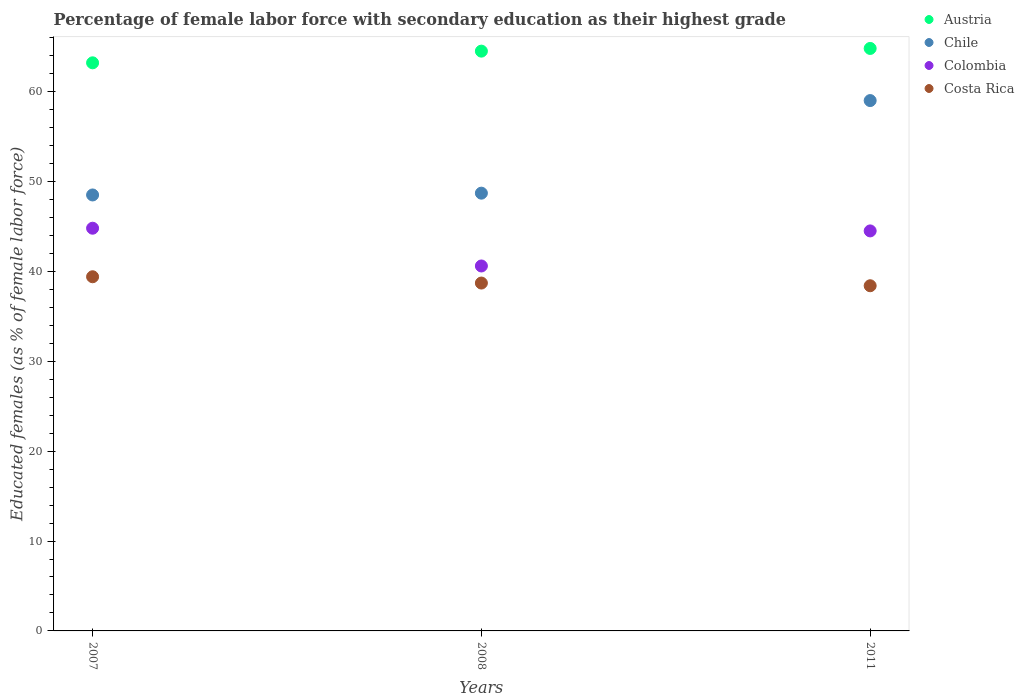How many different coloured dotlines are there?
Keep it short and to the point. 4. Is the number of dotlines equal to the number of legend labels?
Your answer should be compact. Yes. What is the percentage of female labor force with secondary education in Chile in 2007?
Offer a very short reply. 48.5. Across all years, what is the maximum percentage of female labor force with secondary education in Costa Rica?
Ensure brevity in your answer.  39.4. Across all years, what is the minimum percentage of female labor force with secondary education in Chile?
Your answer should be very brief. 48.5. In which year was the percentage of female labor force with secondary education in Chile minimum?
Make the answer very short. 2007. What is the total percentage of female labor force with secondary education in Chile in the graph?
Your answer should be compact. 156.2. What is the difference between the percentage of female labor force with secondary education in Colombia in 2007 and that in 2011?
Make the answer very short. 0.3. What is the difference between the percentage of female labor force with secondary education in Chile in 2011 and the percentage of female labor force with secondary education in Colombia in 2008?
Make the answer very short. 18.4. What is the average percentage of female labor force with secondary education in Chile per year?
Your answer should be compact. 52.07. In how many years, is the percentage of female labor force with secondary education in Colombia greater than 20 %?
Give a very brief answer. 3. What is the ratio of the percentage of female labor force with secondary education in Costa Rica in 2008 to that in 2011?
Give a very brief answer. 1.01. Is the difference between the percentage of female labor force with secondary education in Costa Rica in 2007 and 2011 greater than the difference between the percentage of female labor force with secondary education in Chile in 2007 and 2011?
Keep it short and to the point. Yes. What is the difference between the highest and the second highest percentage of female labor force with secondary education in Austria?
Offer a very short reply. 0.3. In how many years, is the percentage of female labor force with secondary education in Chile greater than the average percentage of female labor force with secondary education in Chile taken over all years?
Your answer should be very brief. 1. Is it the case that in every year, the sum of the percentage of female labor force with secondary education in Austria and percentage of female labor force with secondary education in Chile  is greater than the percentage of female labor force with secondary education in Colombia?
Make the answer very short. Yes. Is the percentage of female labor force with secondary education in Colombia strictly greater than the percentage of female labor force with secondary education in Austria over the years?
Provide a succinct answer. No. Is the percentage of female labor force with secondary education in Austria strictly less than the percentage of female labor force with secondary education in Chile over the years?
Make the answer very short. No. How many dotlines are there?
Provide a succinct answer. 4. How many years are there in the graph?
Give a very brief answer. 3. What is the difference between two consecutive major ticks on the Y-axis?
Your answer should be very brief. 10. Are the values on the major ticks of Y-axis written in scientific E-notation?
Your answer should be very brief. No. Where does the legend appear in the graph?
Your answer should be compact. Top right. How many legend labels are there?
Provide a short and direct response. 4. How are the legend labels stacked?
Keep it short and to the point. Vertical. What is the title of the graph?
Make the answer very short. Percentage of female labor force with secondary education as their highest grade. Does "Tunisia" appear as one of the legend labels in the graph?
Give a very brief answer. No. What is the label or title of the Y-axis?
Your response must be concise. Educated females (as % of female labor force). What is the Educated females (as % of female labor force) of Austria in 2007?
Make the answer very short. 63.2. What is the Educated females (as % of female labor force) in Chile in 2007?
Provide a succinct answer. 48.5. What is the Educated females (as % of female labor force) of Colombia in 2007?
Provide a short and direct response. 44.8. What is the Educated females (as % of female labor force) of Costa Rica in 2007?
Your answer should be compact. 39.4. What is the Educated females (as % of female labor force) in Austria in 2008?
Make the answer very short. 64.5. What is the Educated females (as % of female labor force) of Chile in 2008?
Keep it short and to the point. 48.7. What is the Educated females (as % of female labor force) in Colombia in 2008?
Provide a succinct answer. 40.6. What is the Educated females (as % of female labor force) of Costa Rica in 2008?
Provide a short and direct response. 38.7. What is the Educated females (as % of female labor force) of Austria in 2011?
Ensure brevity in your answer.  64.8. What is the Educated females (as % of female labor force) of Chile in 2011?
Provide a succinct answer. 59. What is the Educated females (as % of female labor force) of Colombia in 2011?
Your answer should be very brief. 44.5. What is the Educated females (as % of female labor force) of Costa Rica in 2011?
Provide a succinct answer. 38.4. Across all years, what is the maximum Educated females (as % of female labor force) of Austria?
Give a very brief answer. 64.8. Across all years, what is the maximum Educated females (as % of female labor force) of Colombia?
Provide a succinct answer. 44.8. Across all years, what is the maximum Educated females (as % of female labor force) of Costa Rica?
Your answer should be compact. 39.4. Across all years, what is the minimum Educated females (as % of female labor force) in Austria?
Provide a succinct answer. 63.2. Across all years, what is the minimum Educated females (as % of female labor force) of Chile?
Give a very brief answer. 48.5. Across all years, what is the minimum Educated females (as % of female labor force) in Colombia?
Give a very brief answer. 40.6. Across all years, what is the minimum Educated females (as % of female labor force) of Costa Rica?
Your answer should be compact. 38.4. What is the total Educated females (as % of female labor force) in Austria in the graph?
Keep it short and to the point. 192.5. What is the total Educated females (as % of female labor force) of Chile in the graph?
Your answer should be compact. 156.2. What is the total Educated females (as % of female labor force) of Colombia in the graph?
Provide a short and direct response. 129.9. What is the total Educated females (as % of female labor force) in Costa Rica in the graph?
Make the answer very short. 116.5. What is the difference between the Educated females (as % of female labor force) in Austria in 2007 and that in 2008?
Provide a succinct answer. -1.3. What is the difference between the Educated females (as % of female labor force) of Colombia in 2007 and that in 2008?
Make the answer very short. 4.2. What is the difference between the Educated females (as % of female labor force) in Costa Rica in 2007 and that in 2008?
Provide a succinct answer. 0.7. What is the difference between the Educated females (as % of female labor force) in Austria in 2007 and that in 2011?
Give a very brief answer. -1.6. What is the difference between the Educated females (as % of female labor force) of Chile in 2007 and that in 2011?
Ensure brevity in your answer.  -10.5. What is the difference between the Educated females (as % of female labor force) of Costa Rica in 2007 and that in 2011?
Your response must be concise. 1. What is the difference between the Educated females (as % of female labor force) of Austria in 2008 and that in 2011?
Give a very brief answer. -0.3. What is the difference between the Educated females (as % of female labor force) in Chile in 2008 and that in 2011?
Offer a terse response. -10.3. What is the difference between the Educated females (as % of female labor force) in Colombia in 2008 and that in 2011?
Your response must be concise. -3.9. What is the difference between the Educated females (as % of female labor force) of Costa Rica in 2008 and that in 2011?
Give a very brief answer. 0.3. What is the difference between the Educated females (as % of female labor force) of Austria in 2007 and the Educated females (as % of female labor force) of Colombia in 2008?
Your answer should be compact. 22.6. What is the difference between the Educated females (as % of female labor force) of Chile in 2007 and the Educated females (as % of female labor force) of Costa Rica in 2008?
Offer a terse response. 9.8. What is the difference between the Educated females (as % of female labor force) of Austria in 2007 and the Educated females (as % of female labor force) of Costa Rica in 2011?
Provide a short and direct response. 24.8. What is the difference between the Educated females (as % of female labor force) in Chile in 2007 and the Educated females (as % of female labor force) in Colombia in 2011?
Provide a short and direct response. 4. What is the difference between the Educated females (as % of female labor force) in Colombia in 2007 and the Educated females (as % of female labor force) in Costa Rica in 2011?
Your answer should be compact. 6.4. What is the difference between the Educated females (as % of female labor force) in Austria in 2008 and the Educated females (as % of female labor force) in Colombia in 2011?
Your answer should be compact. 20. What is the difference between the Educated females (as % of female labor force) in Austria in 2008 and the Educated females (as % of female labor force) in Costa Rica in 2011?
Provide a succinct answer. 26.1. What is the difference between the Educated females (as % of female labor force) in Chile in 2008 and the Educated females (as % of female labor force) in Colombia in 2011?
Give a very brief answer. 4.2. What is the difference between the Educated females (as % of female labor force) in Chile in 2008 and the Educated females (as % of female labor force) in Costa Rica in 2011?
Offer a terse response. 10.3. What is the average Educated females (as % of female labor force) of Austria per year?
Provide a short and direct response. 64.17. What is the average Educated females (as % of female labor force) of Chile per year?
Ensure brevity in your answer.  52.07. What is the average Educated females (as % of female labor force) in Colombia per year?
Offer a very short reply. 43.3. What is the average Educated females (as % of female labor force) of Costa Rica per year?
Your response must be concise. 38.83. In the year 2007, what is the difference between the Educated females (as % of female labor force) in Austria and Educated females (as % of female labor force) in Chile?
Provide a short and direct response. 14.7. In the year 2007, what is the difference between the Educated females (as % of female labor force) in Austria and Educated females (as % of female labor force) in Costa Rica?
Provide a short and direct response. 23.8. In the year 2007, what is the difference between the Educated females (as % of female labor force) of Chile and Educated females (as % of female labor force) of Colombia?
Keep it short and to the point. 3.7. In the year 2007, what is the difference between the Educated females (as % of female labor force) of Chile and Educated females (as % of female labor force) of Costa Rica?
Your answer should be compact. 9.1. In the year 2007, what is the difference between the Educated females (as % of female labor force) of Colombia and Educated females (as % of female labor force) of Costa Rica?
Your answer should be compact. 5.4. In the year 2008, what is the difference between the Educated females (as % of female labor force) in Austria and Educated females (as % of female labor force) in Colombia?
Your response must be concise. 23.9. In the year 2008, what is the difference between the Educated females (as % of female labor force) in Austria and Educated females (as % of female labor force) in Costa Rica?
Make the answer very short. 25.8. In the year 2008, what is the difference between the Educated females (as % of female labor force) in Colombia and Educated females (as % of female labor force) in Costa Rica?
Your answer should be very brief. 1.9. In the year 2011, what is the difference between the Educated females (as % of female labor force) in Austria and Educated females (as % of female labor force) in Colombia?
Give a very brief answer. 20.3. In the year 2011, what is the difference between the Educated females (as % of female labor force) in Austria and Educated females (as % of female labor force) in Costa Rica?
Your answer should be very brief. 26.4. In the year 2011, what is the difference between the Educated females (as % of female labor force) in Chile and Educated females (as % of female labor force) in Colombia?
Offer a very short reply. 14.5. In the year 2011, what is the difference between the Educated females (as % of female labor force) of Chile and Educated females (as % of female labor force) of Costa Rica?
Your answer should be compact. 20.6. What is the ratio of the Educated females (as % of female labor force) of Austria in 2007 to that in 2008?
Your answer should be compact. 0.98. What is the ratio of the Educated females (as % of female labor force) of Colombia in 2007 to that in 2008?
Provide a short and direct response. 1.1. What is the ratio of the Educated females (as % of female labor force) of Costa Rica in 2007 to that in 2008?
Your answer should be very brief. 1.02. What is the ratio of the Educated females (as % of female labor force) in Austria in 2007 to that in 2011?
Offer a very short reply. 0.98. What is the ratio of the Educated females (as % of female labor force) of Chile in 2007 to that in 2011?
Make the answer very short. 0.82. What is the ratio of the Educated females (as % of female labor force) of Colombia in 2007 to that in 2011?
Your answer should be very brief. 1.01. What is the ratio of the Educated females (as % of female labor force) of Costa Rica in 2007 to that in 2011?
Your response must be concise. 1.03. What is the ratio of the Educated females (as % of female labor force) in Austria in 2008 to that in 2011?
Ensure brevity in your answer.  1. What is the ratio of the Educated females (as % of female labor force) of Chile in 2008 to that in 2011?
Ensure brevity in your answer.  0.83. What is the ratio of the Educated females (as % of female labor force) in Colombia in 2008 to that in 2011?
Give a very brief answer. 0.91. What is the ratio of the Educated females (as % of female labor force) in Costa Rica in 2008 to that in 2011?
Your response must be concise. 1.01. What is the difference between the highest and the second highest Educated females (as % of female labor force) of Chile?
Your answer should be very brief. 10.3. What is the difference between the highest and the second highest Educated females (as % of female labor force) in Costa Rica?
Provide a short and direct response. 0.7. What is the difference between the highest and the lowest Educated females (as % of female labor force) in Colombia?
Offer a very short reply. 4.2. What is the difference between the highest and the lowest Educated females (as % of female labor force) in Costa Rica?
Keep it short and to the point. 1. 